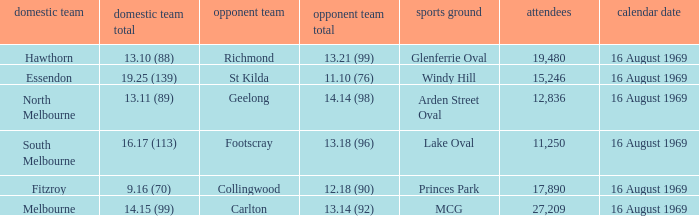Who was home at Princes Park? 9.16 (70). 